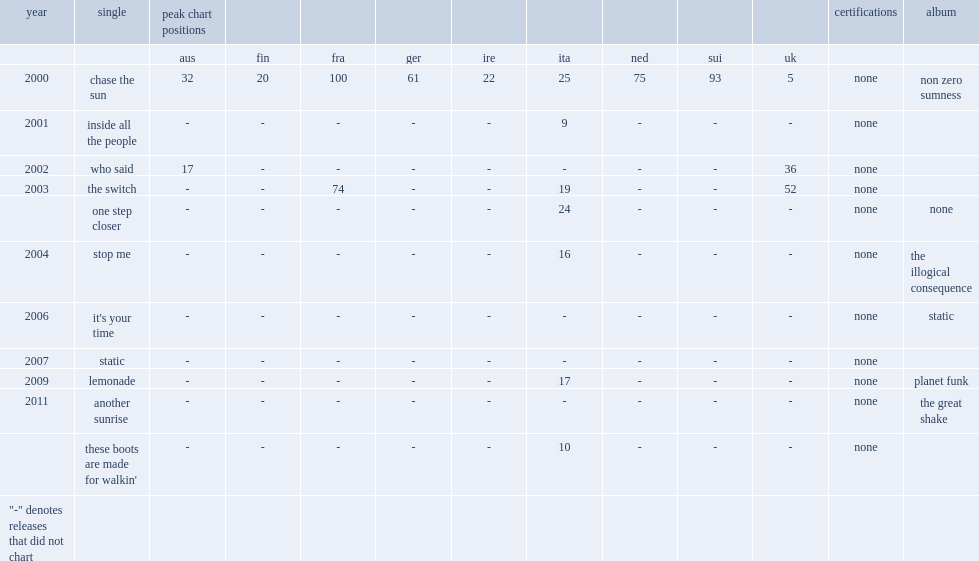Which ablum of planet funk released the single "lemonade" in 2009? Planet funk. 